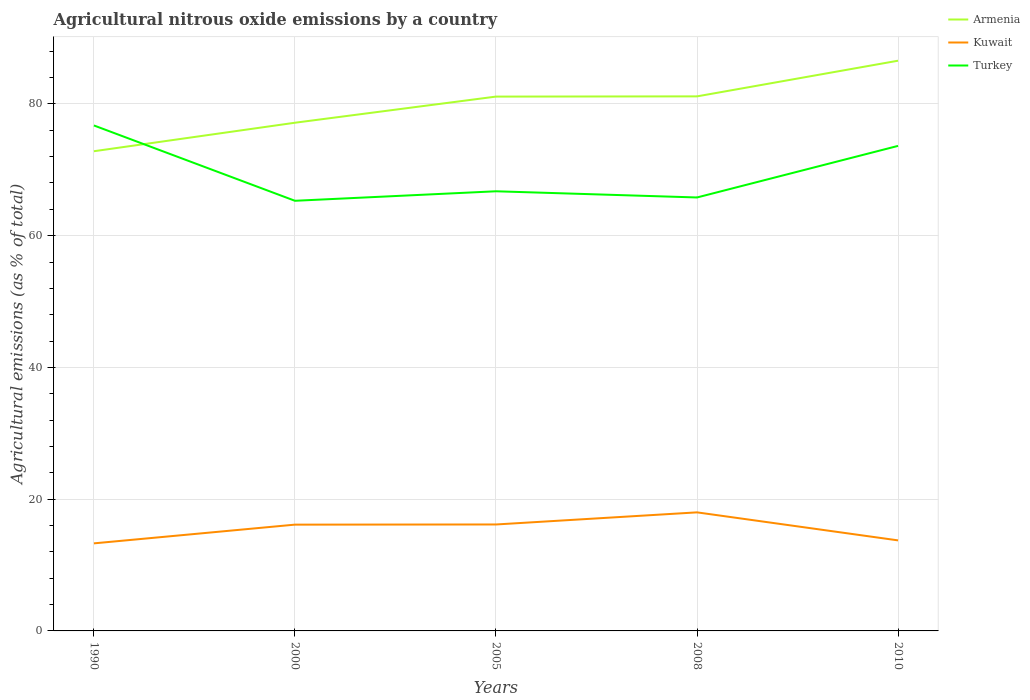Does the line corresponding to Kuwait intersect with the line corresponding to Armenia?
Your response must be concise. No. Across all years, what is the maximum amount of agricultural nitrous oxide emitted in Armenia?
Provide a short and direct response. 72.82. What is the total amount of agricultural nitrous oxide emitted in Turkey in the graph?
Ensure brevity in your answer.  0.94. What is the difference between the highest and the second highest amount of agricultural nitrous oxide emitted in Kuwait?
Provide a short and direct response. 4.71. What is the difference between the highest and the lowest amount of agricultural nitrous oxide emitted in Turkey?
Provide a short and direct response. 2. Are the values on the major ticks of Y-axis written in scientific E-notation?
Your answer should be very brief. No. Does the graph contain any zero values?
Offer a terse response. No. Does the graph contain grids?
Ensure brevity in your answer.  Yes. Where does the legend appear in the graph?
Offer a terse response. Top right. How are the legend labels stacked?
Your answer should be very brief. Vertical. What is the title of the graph?
Give a very brief answer. Agricultural nitrous oxide emissions by a country. Does "Panama" appear as one of the legend labels in the graph?
Offer a very short reply. No. What is the label or title of the X-axis?
Your answer should be very brief. Years. What is the label or title of the Y-axis?
Provide a short and direct response. Agricultural emissions (as % of total). What is the Agricultural emissions (as % of total) in Armenia in 1990?
Your answer should be compact. 72.82. What is the Agricultural emissions (as % of total) in Kuwait in 1990?
Ensure brevity in your answer.  13.29. What is the Agricultural emissions (as % of total) of Turkey in 1990?
Offer a very short reply. 76.73. What is the Agricultural emissions (as % of total) in Armenia in 2000?
Provide a succinct answer. 77.14. What is the Agricultural emissions (as % of total) in Kuwait in 2000?
Your answer should be compact. 16.13. What is the Agricultural emissions (as % of total) in Turkey in 2000?
Keep it short and to the point. 65.3. What is the Agricultural emissions (as % of total) of Armenia in 2005?
Your answer should be compact. 81.11. What is the Agricultural emissions (as % of total) of Kuwait in 2005?
Provide a short and direct response. 16.16. What is the Agricultural emissions (as % of total) in Turkey in 2005?
Provide a succinct answer. 66.74. What is the Agricultural emissions (as % of total) in Armenia in 2008?
Your response must be concise. 81.15. What is the Agricultural emissions (as % of total) of Kuwait in 2008?
Your response must be concise. 18. What is the Agricultural emissions (as % of total) in Turkey in 2008?
Your response must be concise. 65.8. What is the Agricultural emissions (as % of total) of Armenia in 2010?
Give a very brief answer. 86.56. What is the Agricultural emissions (as % of total) in Kuwait in 2010?
Offer a very short reply. 13.74. What is the Agricultural emissions (as % of total) in Turkey in 2010?
Ensure brevity in your answer.  73.63. Across all years, what is the maximum Agricultural emissions (as % of total) in Armenia?
Ensure brevity in your answer.  86.56. Across all years, what is the maximum Agricultural emissions (as % of total) in Kuwait?
Keep it short and to the point. 18. Across all years, what is the maximum Agricultural emissions (as % of total) of Turkey?
Your answer should be very brief. 76.73. Across all years, what is the minimum Agricultural emissions (as % of total) of Armenia?
Ensure brevity in your answer.  72.82. Across all years, what is the minimum Agricultural emissions (as % of total) of Kuwait?
Your answer should be compact. 13.29. Across all years, what is the minimum Agricultural emissions (as % of total) in Turkey?
Keep it short and to the point. 65.3. What is the total Agricultural emissions (as % of total) in Armenia in the graph?
Your response must be concise. 398.78. What is the total Agricultural emissions (as % of total) of Kuwait in the graph?
Give a very brief answer. 77.33. What is the total Agricultural emissions (as % of total) of Turkey in the graph?
Keep it short and to the point. 348.2. What is the difference between the Agricultural emissions (as % of total) in Armenia in 1990 and that in 2000?
Provide a short and direct response. -4.32. What is the difference between the Agricultural emissions (as % of total) in Kuwait in 1990 and that in 2000?
Make the answer very short. -2.84. What is the difference between the Agricultural emissions (as % of total) of Turkey in 1990 and that in 2000?
Offer a very short reply. 11.43. What is the difference between the Agricultural emissions (as % of total) in Armenia in 1990 and that in 2005?
Make the answer very short. -8.29. What is the difference between the Agricultural emissions (as % of total) in Kuwait in 1990 and that in 2005?
Provide a short and direct response. -2.87. What is the difference between the Agricultural emissions (as % of total) of Turkey in 1990 and that in 2005?
Offer a terse response. 9.99. What is the difference between the Agricultural emissions (as % of total) in Armenia in 1990 and that in 2008?
Offer a terse response. -8.33. What is the difference between the Agricultural emissions (as % of total) of Kuwait in 1990 and that in 2008?
Provide a short and direct response. -4.71. What is the difference between the Agricultural emissions (as % of total) in Turkey in 1990 and that in 2008?
Give a very brief answer. 10.93. What is the difference between the Agricultural emissions (as % of total) in Armenia in 1990 and that in 2010?
Ensure brevity in your answer.  -13.74. What is the difference between the Agricultural emissions (as % of total) in Kuwait in 1990 and that in 2010?
Provide a short and direct response. -0.45. What is the difference between the Agricultural emissions (as % of total) in Turkey in 1990 and that in 2010?
Offer a terse response. 3.1. What is the difference between the Agricultural emissions (as % of total) in Armenia in 2000 and that in 2005?
Your answer should be very brief. -3.97. What is the difference between the Agricultural emissions (as % of total) in Kuwait in 2000 and that in 2005?
Your answer should be very brief. -0.02. What is the difference between the Agricultural emissions (as % of total) of Turkey in 2000 and that in 2005?
Your answer should be very brief. -1.44. What is the difference between the Agricultural emissions (as % of total) of Armenia in 2000 and that in 2008?
Your answer should be compact. -4. What is the difference between the Agricultural emissions (as % of total) of Kuwait in 2000 and that in 2008?
Offer a very short reply. -1.86. What is the difference between the Agricultural emissions (as % of total) in Turkey in 2000 and that in 2008?
Your answer should be compact. -0.5. What is the difference between the Agricultural emissions (as % of total) in Armenia in 2000 and that in 2010?
Your answer should be very brief. -9.42. What is the difference between the Agricultural emissions (as % of total) in Kuwait in 2000 and that in 2010?
Your answer should be compact. 2.39. What is the difference between the Agricultural emissions (as % of total) in Turkey in 2000 and that in 2010?
Make the answer very short. -8.33. What is the difference between the Agricultural emissions (as % of total) in Armenia in 2005 and that in 2008?
Give a very brief answer. -0.03. What is the difference between the Agricultural emissions (as % of total) in Kuwait in 2005 and that in 2008?
Offer a very short reply. -1.84. What is the difference between the Agricultural emissions (as % of total) in Turkey in 2005 and that in 2008?
Give a very brief answer. 0.94. What is the difference between the Agricultural emissions (as % of total) in Armenia in 2005 and that in 2010?
Ensure brevity in your answer.  -5.45. What is the difference between the Agricultural emissions (as % of total) of Kuwait in 2005 and that in 2010?
Make the answer very short. 2.42. What is the difference between the Agricultural emissions (as % of total) of Turkey in 2005 and that in 2010?
Offer a terse response. -6.89. What is the difference between the Agricultural emissions (as % of total) in Armenia in 2008 and that in 2010?
Give a very brief answer. -5.41. What is the difference between the Agricultural emissions (as % of total) in Kuwait in 2008 and that in 2010?
Keep it short and to the point. 4.25. What is the difference between the Agricultural emissions (as % of total) in Turkey in 2008 and that in 2010?
Your answer should be very brief. -7.83. What is the difference between the Agricultural emissions (as % of total) in Armenia in 1990 and the Agricultural emissions (as % of total) in Kuwait in 2000?
Your answer should be very brief. 56.69. What is the difference between the Agricultural emissions (as % of total) of Armenia in 1990 and the Agricultural emissions (as % of total) of Turkey in 2000?
Provide a succinct answer. 7.52. What is the difference between the Agricultural emissions (as % of total) of Kuwait in 1990 and the Agricultural emissions (as % of total) of Turkey in 2000?
Ensure brevity in your answer.  -52.01. What is the difference between the Agricultural emissions (as % of total) of Armenia in 1990 and the Agricultural emissions (as % of total) of Kuwait in 2005?
Make the answer very short. 56.66. What is the difference between the Agricultural emissions (as % of total) of Armenia in 1990 and the Agricultural emissions (as % of total) of Turkey in 2005?
Provide a short and direct response. 6.08. What is the difference between the Agricultural emissions (as % of total) of Kuwait in 1990 and the Agricultural emissions (as % of total) of Turkey in 2005?
Ensure brevity in your answer.  -53.45. What is the difference between the Agricultural emissions (as % of total) in Armenia in 1990 and the Agricultural emissions (as % of total) in Kuwait in 2008?
Provide a succinct answer. 54.82. What is the difference between the Agricultural emissions (as % of total) of Armenia in 1990 and the Agricultural emissions (as % of total) of Turkey in 2008?
Offer a terse response. 7.02. What is the difference between the Agricultural emissions (as % of total) of Kuwait in 1990 and the Agricultural emissions (as % of total) of Turkey in 2008?
Make the answer very short. -52.51. What is the difference between the Agricultural emissions (as % of total) in Armenia in 1990 and the Agricultural emissions (as % of total) in Kuwait in 2010?
Your answer should be very brief. 59.08. What is the difference between the Agricultural emissions (as % of total) in Armenia in 1990 and the Agricultural emissions (as % of total) in Turkey in 2010?
Offer a terse response. -0.81. What is the difference between the Agricultural emissions (as % of total) in Kuwait in 1990 and the Agricultural emissions (as % of total) in Turkey in 2010?
Make the answer very short. -60.34. What is the difference between the Agricultural emissions (as % of total) of Armenia in 2000 and the Agricultural emissions (as % of total) of Kuwait in 2005?
Your response must be concise. 60.99. What is the difference between the Agricultural emissions (as % of total) in Armenia in 2000 and the Agricultural emissions (as % of total) in Turkey in 2005?
Offer a very short reply. 10.41. What is the difference between the Agricultural emissions (as % of total) in Kuwait in 2000 and the Agricultural emissions (as % of total) in Turkey in 2005?
Ensure brevity in your answer.  -50.6. What is the difference between the Agricultural emissions (as % of total) of Armenia in 2000 and the Agricultural emissions (as % of total) of Kuwait in 2008?
Your answer should be very brief. 59.15. What is the difference between the Agricultural emissions (as % of total) in Armenia in 2000 and the Agricultural emissions (as % of total) in Turkey in 2008?
Your response must be concise. 11.35. What is the difference between the Agricultural emissions (as % of total) of Kuwait in 2000 and the Agricultural emissions (as % of total) of Turkey in 2008?
Offer a very short reply. -49.66. What is the difference between the Agricultural emissions (as % of total) in Armenia in 2000 and the Agricultural emissions (as % of total) in Kuwait in 2010?
Ensure brevity in your answer.  63.4. What is the difference between the Agricultural emissions (as % of total) in Armenia in 2000 and the Agricultural emissions (as % of total) in Turkey in 2010?
Keep it short and to the point. 3.52. What is the difference between the Agricultural emissions (as % of total) in Kuwait in 2000 and the Agricultural emissions (as % of total) in Turkey in 2010?
Make the answer very short. -57.49. What is the difference between the Agricultural emissions (as % of total) of Armenia in 2005 and the Agricultural emissions (as % of total) of Kuwait in 2008?
Your response must be concise. 63.12. What is the difference between the Agricultural emissions (as % of total) of Armenia in 2005 and the Agricultural emissions (as % of total) of Turkey in 2008?
Your response must be concise. 15.31. What is the difference between the Agricultural emissions (as % of total) in Kuwait in 2005 and the Agricultural emissions (as % of total) in Turkey in 2008?
Your response must be concise. -49.64. What is the difference between the Agricultural emissions (as % of total) in Armenia in 2005 and the Agricultural emissions (as % of total) in Kuwait in 2010?
Provide a short and direct response. 67.37. What is the difference between the Agricultural emissions (as % of total) of Armenia in 2005 and the Agricultural emissions (as % of total) of Turkey in 2010?
Ensure brevity in your answer.  7.48. What is the difference between the Agricultural emissions (as % of total) of Kuwait in 2005 and the Agricultural emissions (as % of total) of Turkey in 2010?
Your answer should be compact. -57.47. What is the difference between the Agricultural emissions (as % of total) of Armenia in 2008 and the Agricultural emissions (as % of total) of Kuwait in 2010?
Keep it short and to the point. 67.4. What is the difference between the Agricultural emissions (as % of total) in Armenia in 2008 and the Agricultural emissions (as % of total) in Turkey in 2010?
Offer a very short reply. 7.52. What is the difference between the Agricultural emissions (as % of total) of Kuwait in 2008 and the Agricultural emissions (as % of total) of Turkey in 2010?
Your answer should be very brief. -55.63. What is the average Agricultural emissions (as % of total) of Armenia per year?
Your answer should be very brief. 79.76. What is the average Agricultural emissions (as % of total) in Kuwait per year?
Provide a succinct answer. 15.47. What is the average Agricultural emissions (as % of total) in Turkey per year?
Your response must be concise. 69.64. In the year 1990, what is the difference between the Agricultural emissions (as % of total) in Armenia and Agricultural emissions (as % of total) in Kuwait?
Ensure brevity in your answer.  59.53. In the year 1990, what is the difference between the Agricultural emissions (as % of total) in Armenia and Agricultural emissions (as % of total) in Turkey?
Provide a succinct answer. -3.91. In the year 1990, what is the difference between the Agricultural emissions (as % of total) in Kuwait and Agricultural emissions (as % of total) in Turkey?
Give a very brief answer. -63.44. In the year 2000, what is the difference between the Agricultural emissions (as % of total) in Armenia and Agricultural emissions (as % of total) in Kuwait?
Offer a terse response. 61.01. In the year 2000, what is the difference between the Agricultural emissions (as % of total) of Armenia and Agricultural emissions (as % of total) of Turkey?
Offer a terse response. 11.85. In the year 2000, what is the difference between the Agricultural emissions (as % of total) of Kuwait and Agricultural emissions (as % of total) of Turkey?
Ensure brevity in your answer.  -49.16. In the year 2005, what is the difference between the Agricultural emissions (as % of total) of Armenia and Agricultural emissions (as % of total) of Kuwait?
Keep it short and to the point. 64.95. In the year 2005, what is the difference between the Agricultural emissions (as % of total) in Armenia and Agricultural emissions (as % of total) in Turkey?
Keep it short and to the point. 14.38. In the year 2005, what is the difference between the Agricultural emissions (as % of total) of Kuwait and Agricultural emissions (as % of total) of Turkey?
Offer a terse response. -50.58. In the year 2008, what is the difference between the Agricultural emissions (as % of total) of Armenia and Agricultural emissions (as % of total) of Kuwait?
Make the answer very short. 63.15. In the year 2008, what is the difference between the Agricultural emissions (as % of total) in Armenia and Agricultural emissions (as % of total) in Turkey?
Offer a terse response. 15.35. In the year 2008, what is the difference between the Agricultural emissions (as % of total) of Kuwait and Agricultural emissions (as % of total) of Turkey?
Ensure brevity in your answer.  -47.8. In the year 2010, what is the difference between the Agricultural emissions (as % of total) in Armenia and Agricultural emissions (as % of total) in Kuwait?
Your answer should be compact. 72.82. In the year 2010, what is the difference between the Agricultural emissions (as % of total) of Armenia and Agricultural emissions (as % of total) of Turkey?
Provide a short and direct response. 12.93. In the year 2010, what is the difference between the Agricultural emissions (as % of total) in Kuwait and Agricultural emissions (as % of total) in Turkey?
Give a very brief answer. -59.89. What is the ratio of the Agricultural emissions (as % of total) in Armenia in 1990 to that in 2000?
Your answer should be compact. 0.94. What is the ratio of the Agricultural emissions (as % of total) of Kuwait in 1990 to that in 2000?
Ensure brevity in your answer.  0.82. What is the ratio of the Agricultural emissions (as % of total) of Turkey in 1990 to that in 2000?
Your response must be concise. 1.18. What is the ratio of the Agricultural emissions (as % of total) in Armenia in 1990 to that in 2005?
Provide a short and direct response. 0.9. What is the ratio of the Agricultural emissions (as % of total) of Kuwait in 1990 to that in 2005?
Your answer should be very brief. 0.82. What is the ratio of the Agricultural emissions (as % of total) of Turkey in 1990 to that in 2005?
Keep it short and to the point. 1.15. What is the ratio of the Agricultural emissions (as % of total) of Armenia in 1990 to that in 2008?
Your answer should be very brief. 0.9. What is the ratio of the Agricultural emissions (as % of total) of Kuwait in 1990 to that in 2008?
Make the answer very short. 0.74. What is the ratio of the Agricultural emissions (as % of total) of Turkey in 1990 to that in 2008?
Your answer should be very brief. 1.17. What is the ratio of the Agricultural emissions (as % of total) of Armenia in 1990 to that in 2010?
Give a very brief answer. 0.84. What is the ratio of the Agricultural emissions (as % of total) in Kuwait in 1990 to that in 2010?
Make the answer very short. 0.97. What is the ratio of the Agricultural emissions (as % of total) of Turkey in 1990 to that in 2010?
Give a very brief answer. 1.04. What is the ratio of the Agricultural emissions (as % of total) in Armenia in 2000 to that in 2005?
Keep it short and to the point. 0.95. What is the ratio of the Agricultural emissions (as % of total) in Kuwait in 2000 to that in 2005?
Give a very brief answer. 1. What is the ratio of the Agricultural emissions (as % of total) in Turkey in 2000 to that in 2005?
Keep it short and to the point. 0.98. What is the ratio of the Agricultural emissions (as % of total) of Armenia in 2000 to that in 2008?
Provide a short and direct response. 0.95. What is the ratio of the Agricultural emissions (as % of total) of Kuwait in 2000 to that in 2008?
Give a very brief answer. 0.9. What is the ratio of the Agricultural emissions (as % of total) in Turkey in 2000 to that in 2008?
Provide a succinct answer. 0.99. What is the ratio of the Agricultural emissions (as % of total) in Armenia in 2000 to that in 2010?
Give a very brief answer. 0.89. What is the ratio of the Agricultural emissions (as % of total) of Kuwait in 2000 to that in 2010?
Your answer should be very brief. 1.17. What is the ratio of the Agricultural emissions (as % of total) in Turkey in 2000 to that in 2010?
Your answer should be very brief. 0.89. What is the ratio of the Agricultural emissions (as % of total) of Armenia in 2005 to that in 2008?
Your answer should be very brief. 1. What is the ratio of the Agricultural emissions (as % of total) in Kuwait in 2005 to that in 2008?
Make the answer very short. 0.9. What is the ratio of the Agricultural emissions (as % of total) of Turkey in 2005 to that in 2008?
Keep it short and to the point. 1.01. What is the ratio of the Agricultural emissions (as % of total) in Armenia in 2005 to that in 2010?
Your answer should be compact. 0.94. What is the ratio of the Agricultural emissions (as % of total) of Kuwait in 2005 to that in 2010?
Make the answer very short. 1.18. What is the ratio of the Agricultural emissions (as % of total) in Turkey in 2005 to that in 2010?
Offer a terse response. 0.91. What is the ratio of the Agricultural emissions (as % of total) in Armenia in 2008 to that in 2010?
Provide a succinct answer. 0.94. What is the ratio of the Agricultural emissions (as % of total) in Kuwait in 2008 to that in 2010?
Give a very brief answer. 1.31. What is the ratio of the Agricultural emissions (as % of total) of Turkey in 2008 to that in 2010?
Your answer should be very brief. 0.89. What is the difference between the highest and the second highest Agricultural emissions (as % of total) of Armenia?
Your response must be concise. 5.41. What is the difference between the highest and the second highest Agricultural emissions (as % of total) in Kuwait?
Provide a succinct answer. 1.84. What is the difference between the highest and the second highest Agricultural emissions (as % of total) in Turkey?
Give a very brief answer. 3.1. What is the difference between the highest and the lowest Agricultural emissions (as % of total) of Armenia?
Provide a succinct answer. 13.74. What is the difference between the highest and the lowest Agricultural emissions (as % of total) of Kuwait?
Give a very brief answer. 4.71. What is the difference between the highest and the lowest Agricultural emissions (as % of total) of Turkey?
Make the answer very short. 11.43. 